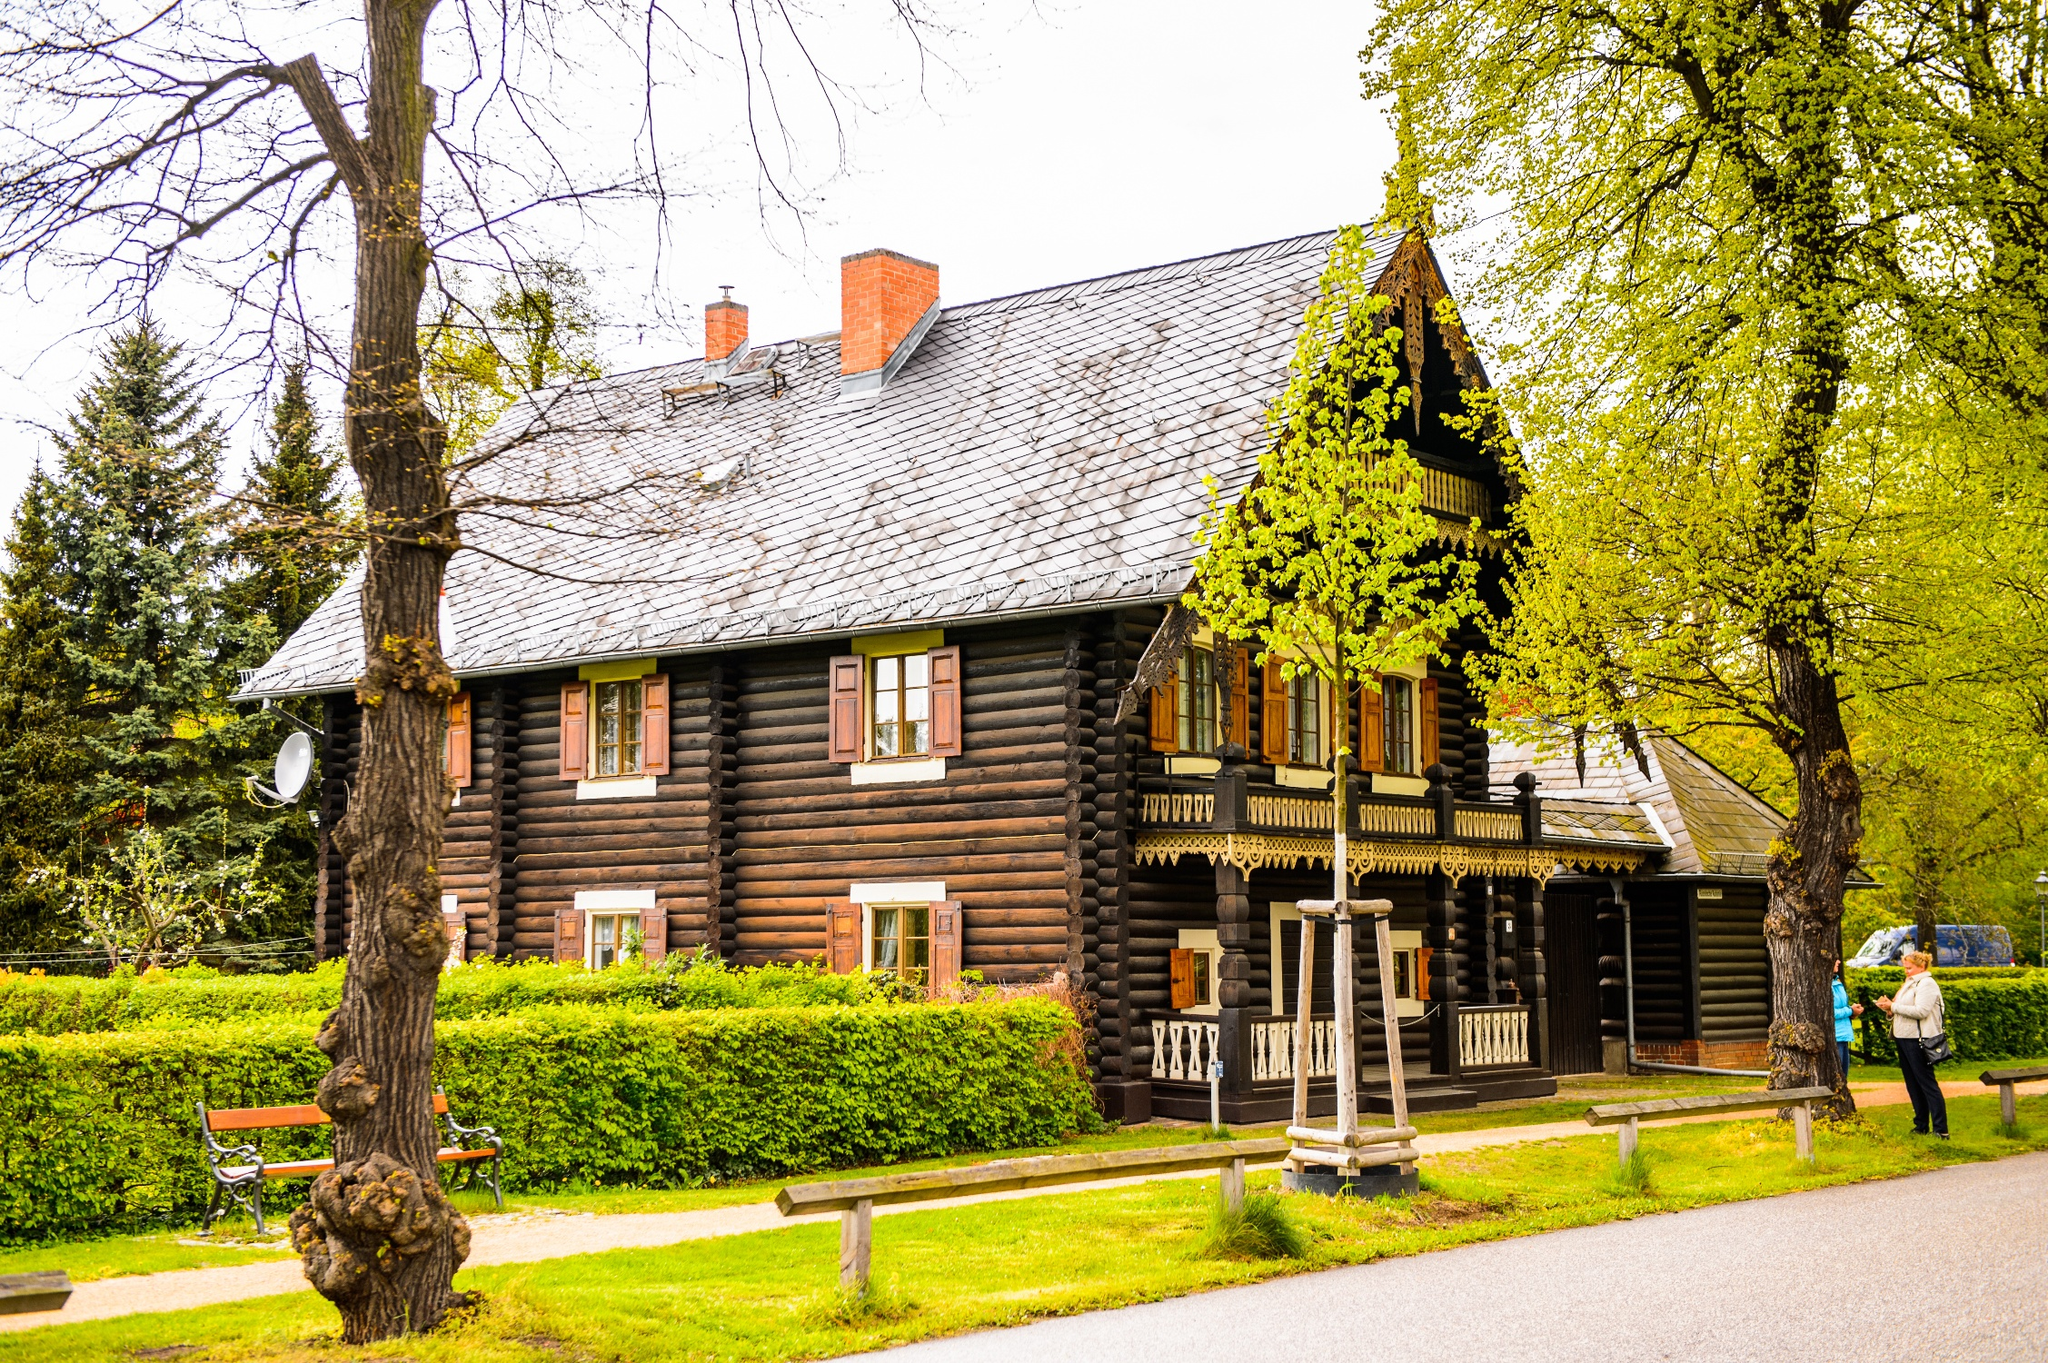Explain the visual content of the image in great detail. The image features a picturesque log cabin with a rustic, yet well-preserved, aesthetic. This charming building is painted in deep, earthy tones of brown, complemented by white trims around the windows and door, enhancing its traditional look. Its steep gabled roof, equipped with a prominent chimney, suggests a warm, inviting interior, ideal for cooler weather. The porch, detailed with a decorative railing, beckons visitors to relax on one of the two wooden benches placed in front, providing a perfect viewpoint to appreciate the surrounding lush garden and mature trees. The setting is serene, emphasized by an overcast sky that softens the light, bathing the scene in a gentle glow. This cabin, possibly situated in a park or rural area, stands as a testament to classic architectural charm amid nature's beauty. 